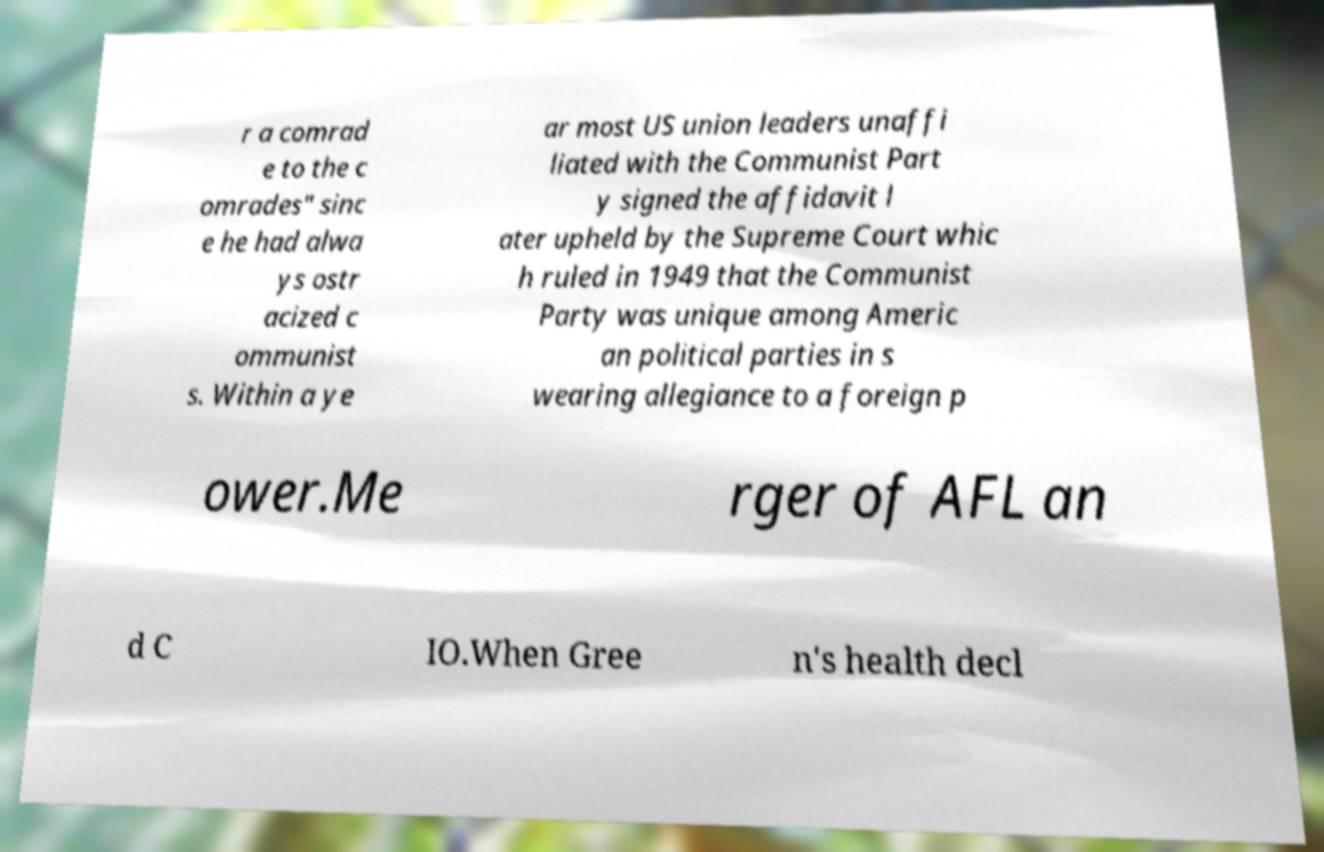There's text embedded in this image that I need extracted. Can you transcribe it verbatim? r a comrad e to the c omrades" sinc e he had alwa ys ostr acized c ommunist s. Within a ye ar most US union leaders unaffi liated with the Communist Part y signed the affidavit l ater upheld by the Supreme Court whic h ruled in 1949 that the Communist Party was unique among Americ an political parties in s wearing allegiance to a foreign p ower.Me rger of AFL an d C IO.When Gree n's health decl 